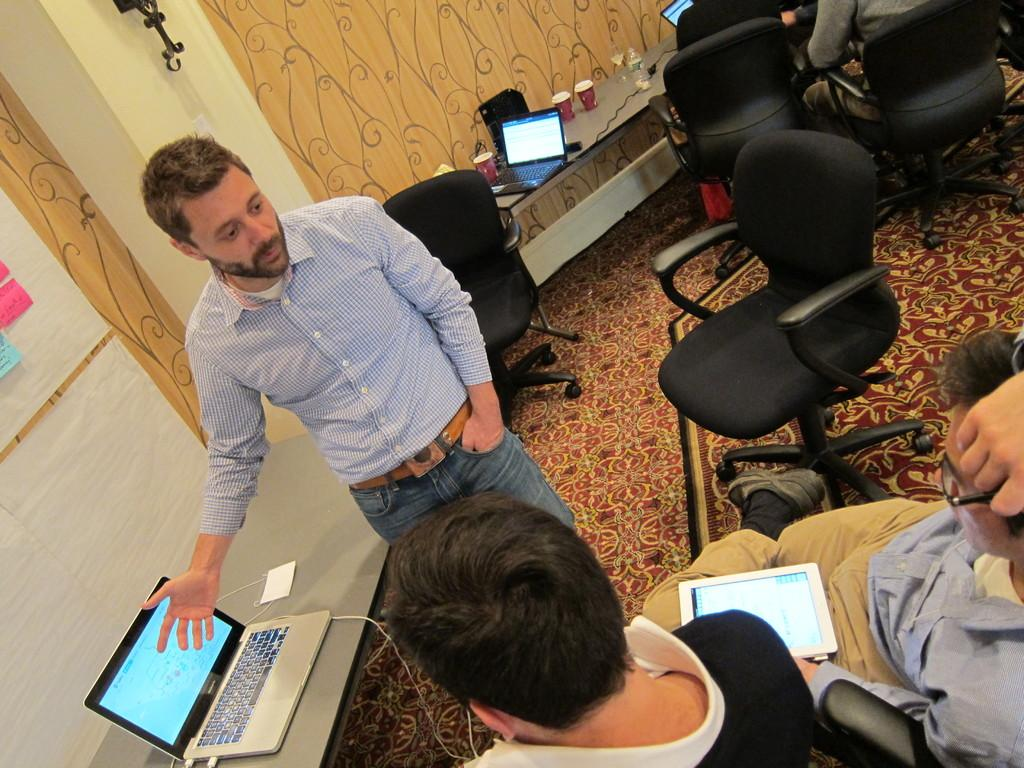What is the main subject of the image? There is a man standing in the image. Where is the man standing? The man is standing on the floor. What can be seen on the table in the image? There are laptops on a table in the image. How many persons are sitting in the image? There are two persons sitting on chairs in the image. What is visible in the background of the image? There is a wall visible in the image. What type of quilt is being used to cover the man's eyes in the image? There is no quilt or any object covering the man's eyes in the image. What thought is the man having in the image? The image does not provide any information about the man's thoughts or emotions. 